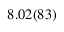Convert formula to latex. <formula><loc_0><loc_0><loc_500><loc_500>8 . 0 2 ( 8 3 )</formula> 